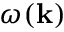Convert formula to latex. <formula><loc_0><loc_0><loc_500><loc_500>\omega ( k )</formula> 